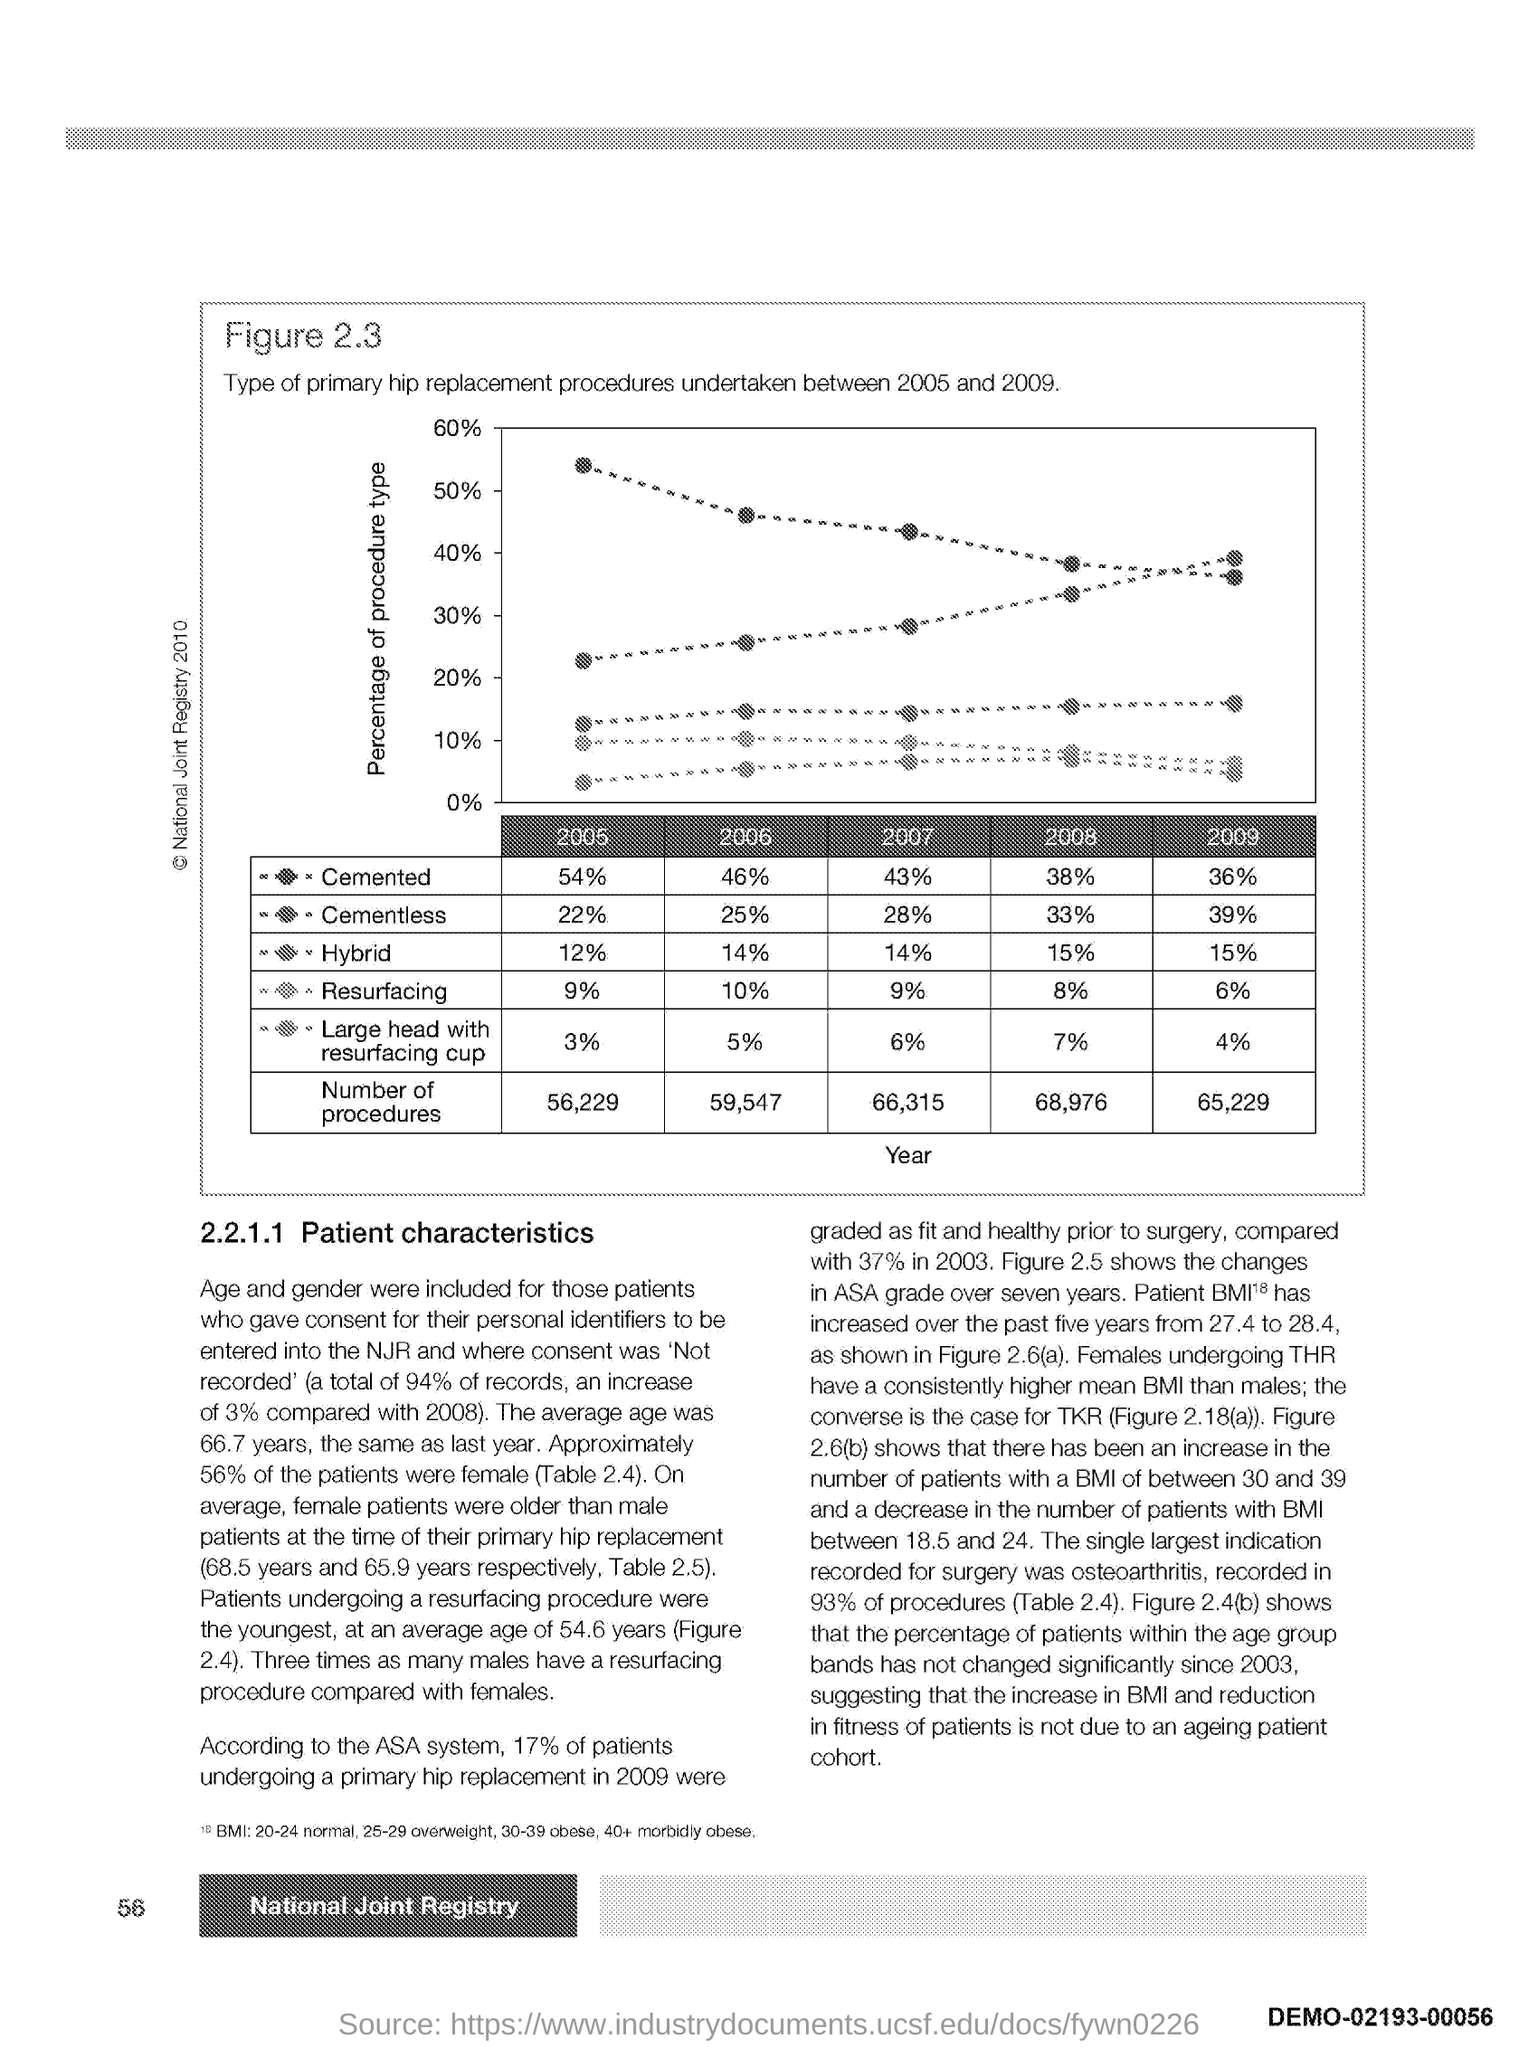List a handful of essential elements in this visual. The heading of the paragraph is 'Patient Characteristics.' The number at the bottom left side of the page is 56. 